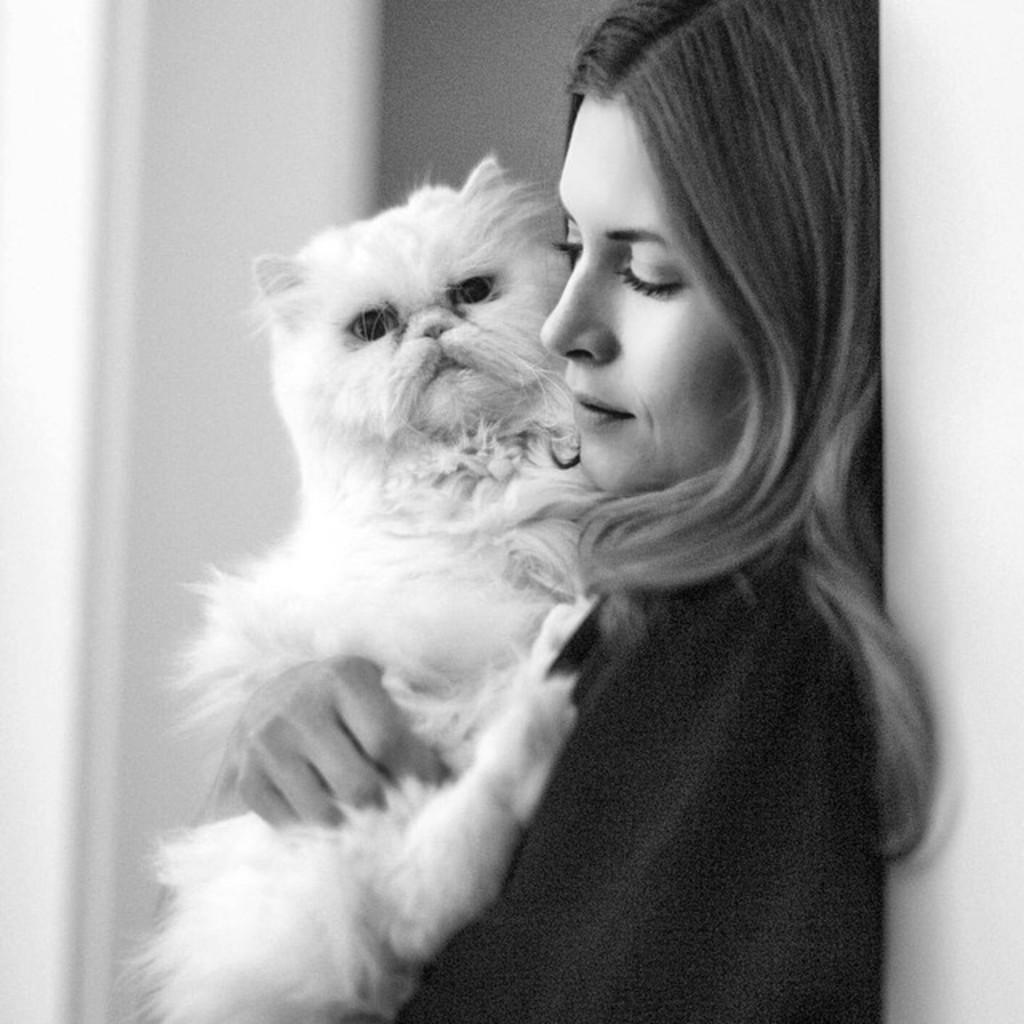Who is the main subject in the image? There is a girl in the image. What is the girl holding in the image? The girl is holding a cat. What type of chess piece is the girl holding in the image? There is no chess piece present in the image; the girl is holding a cat. What type of rock can be seen in the image? There is no rock present in the image; the girl is holding a cat. 